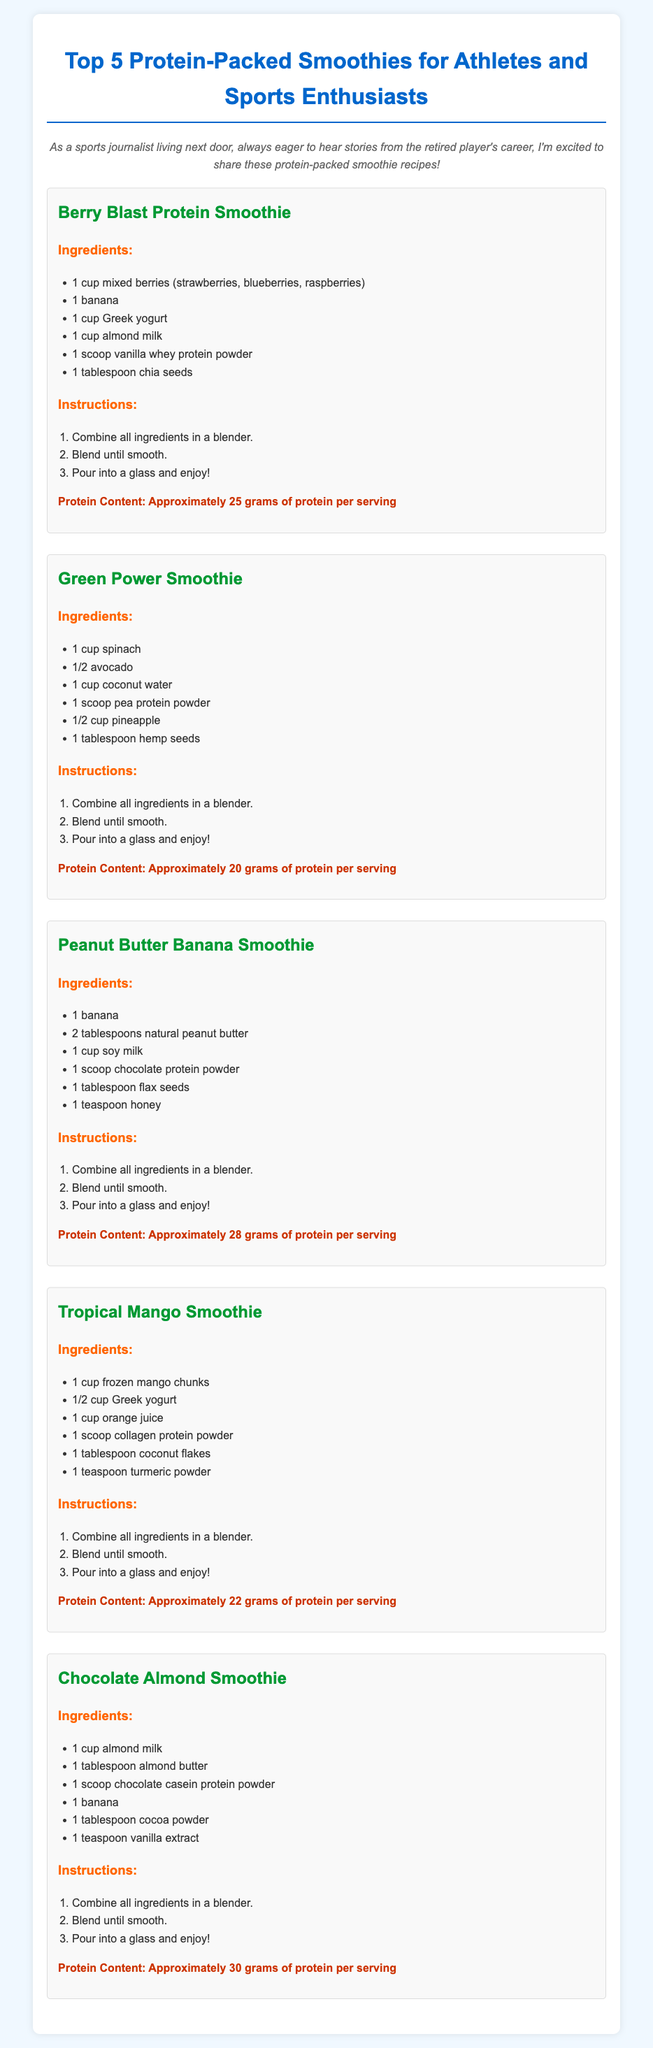What is the protein content of the Berry Blast Protein Smoothie? The protein content is mentioned directly for each smoothie, and for the Berry Blast Protein Smoothie, it states "Approximately 25 grams of protein per serving."
Answer: Approximately 25 grams of protein per serving What ingredients are used in the Green Power Smoothie? The ingredients for the Green Power Smoothie are listed in a bullet point format under the smoothie name, which includes "1 cup spinach, 1/2 avocado, 1 cup coconut water, 1 scoop pea protein powder, 1/2 cup pineapple, 1 tablespoon hemp seeds."
Answer: 1 cup spinach, 1/2 avocado, 1 cup coconut water, 1 scoop pea protein powder, 1/2 cup pineapple, 1 tablespoon hemp seeds Which smoothie has the highest protein content? The highest protein content is identified in the Chocolate Almond Smoothie, which states "Approximately 30 grams of protein per serving."
Answer: Approximately 30 grams of protein per serving How many total smoothies are included in the document? The number of smoothies is found by counting the individual smoothie sections within the document, and there are five smoothies listed.
Answer: 5 What is the main base liquid used in the Peanut Butter Banana Smoothie? The main base liquid in the Peanut Butter Banana Smoothie is specified in the ingredients section as "1 cup soy milk."
Answer: 1 cup soy milk 